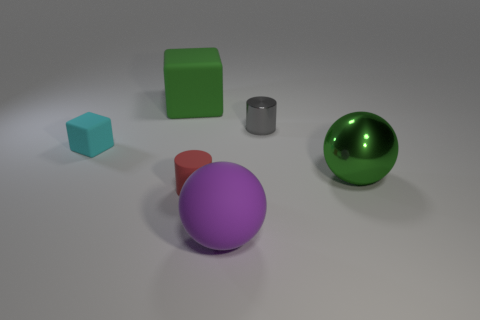Add 4 big yellow rubber cubes. How many objects exist? 10 Subtract all red cylinders. How many cylinders are left? 1 Subtract all brown cylinders. How many green cubes are left? 1 Subtract all cylinders. How many objects are left? 4 Subtract 1 blocks. How many blocks are left? 1 Subtract all purple metal balls. Subtract all small red rubber cylinders. How many objects are left? 5 Add 4 tiny cubes. How many tiny cubes are left? 5 Add 3 large balls. How many large balls exist? 5 Subtract 0 green cylinders. How many objects are left? 6 Subtract all brown spheres. Subtract all green cylinders. How many spheres are left? 2 